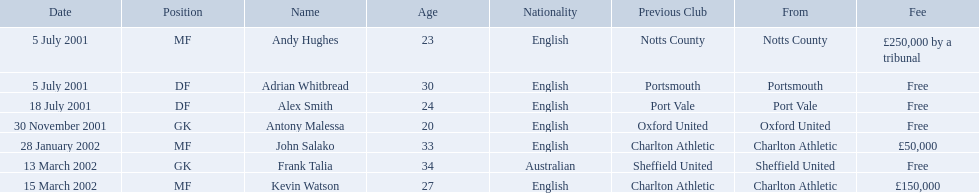Who were all the players? Andy Hughes, Adrian Whitbread, Alex Smith, Antony Malessa, John Salako, Frank Talia, Kevin Watson. What were the transfer fees of these players? £250,000 by a tribunal, Free, Free, Free, £50,000, Free, £150,000. Of these, which belong to andy hughes and john salako? £250,000 by a tribunal, £50,000. Of these, which is larger? £250,000 by a tribunal. Which player commanded this fee? Andy Hughes. Parse the table in full. {'header': ['Date', 'Position', 'Name', 'Age', 'Nationality', 'Previous Club', 'From', 'Fee'], 'rows': [['5 July 2001', 'MF', 'Andy Hughes', '23', 'English', 'Notts County', 'Notts County', '£250,000 by a tribunal'], ['5 July 2001', 'DF', 'Adrian Whitbread', '30', 'English', 'Portsmouth', 'Portsmouth', 'Free'], ['18 July 2001', 'DF', 'Alex Smith', '24', 'English', 'Port Vale', 'Port Vale', 'Free'], ['30 November 2001', 'GK', 'Antony Malessa', '20', 'English', 'Oxford United', 'Oxford United', 'Free'], ['28 January 2002', 'MF', 'John Salako', '33', 'English', 'Charlton Athletic', 'Charlton Athletic', '£50,000'], ['13 March 2002', 'GK', 'Frank Talia', '34', 'Australian', 'Sheffield United', 'Sheffield United', 'Free'], ['15 March 2002', 'MF', 'Kevin Watson', '27', 'English', 'Charlton Athletic', 'Charlton Athletic', '£150,000']]} Which players in the 2001-02 reading f.c. season played the mf position? Andy Hughes, John Salako, Kevin Watson. Of these players, which ones transferred in 2002? John Salako, Kevin Watson. Of these players, who had the highest transfer fee? Kevin Watson. What was this player's transfer fee? £150,000. 